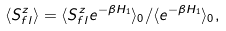Convert formula to latex. <formula><loc_0><loc_0><loc_500><loc_500>\langle S ^ { z } _ { { f } l } \rangle = \langle S ^ { z } _ { { f } l } e ^ { - \beta H _ { 1 } } \rangle _ { 0 } / \langle e ^ { - \beta H _ { 1 } } \rangle _ { 0 } ,</formula> 